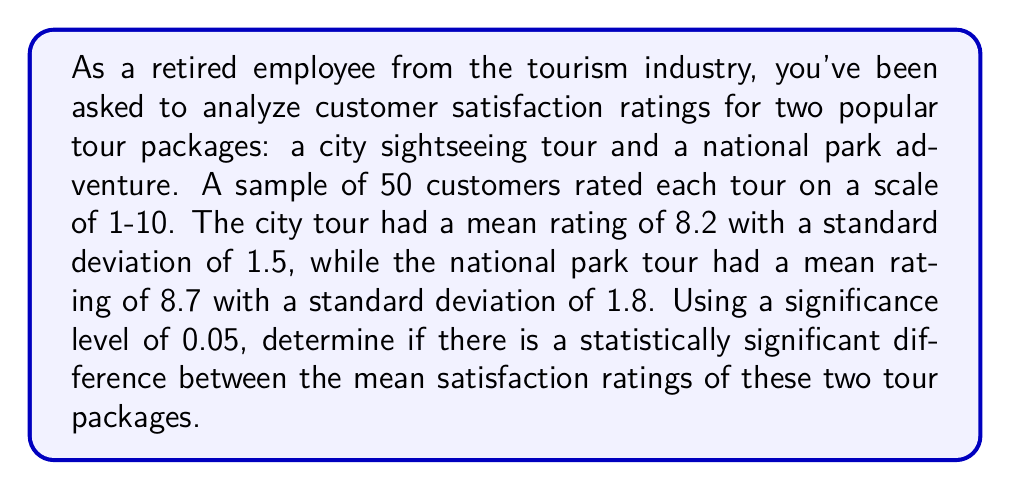Solve this math problem. To determine if there is a statistically significant difference between the mean satisfaction ratings, we'll use a two-sample t-test. We'll follow these steps:

1. State the null and alternative hypotheses:
   $H_0: \mu_1 = \mu_2$ (no difference in mean ratings)
   $H_a: \mu_1 \neq \mu_2$ (there is a difference in mean ratings)

2. Calculate the t-statistic:
   $$t = \frac{\bar{x}_1 - \bar{x}_2}{\sqrt{\frac{s_1^2}{n_1} + \frac{s_2^2}{n_2}}}$$

   Where:
   $\bar{x}_1 = 8.2$ (mean of city tour)
   $\bar{x}_2 = 8.7$ (mean of national park tour)
   $s_1 = 1.5$ (standard deviation of city tour)
   $s_2 = 1.8$ (standard deviation of national park tour)
   $n_1 = n_2 = 50$ (sample size for each tour)

3. Plug in the values:
   $$t = \frac{8.2 - 8.7}{\sqrt{\frac{1.5^2}{50} + \frac{1.8^2}{50}}} = \frac{-0.5}{\sqrt{0.045 + 0.0648}} = \frac{-0.5}{\sqrt{0.1098}} = \frac{-0.5}{0.3313} = -1.509$$

4. Calculate the degrees of freedom (df) using the Welch–Satterthwaite equation:
   $$df = \frac{(\frac{s_1^2}{n_1} + \frac{s_2^2}{n_2})^2}{\frac{(s_1^2/n_1)^2}{n_1-1} + \frac{(s_2^2/n_2)^2}{n_2-1}}$$

   Plugging in the values:
   $$df = \frac{(0.045 + 0.0648)^2}{\frac{0.045^2}{49} + \frac{0.0648^2}{49}} \approx 95.04$$

5. Find the critical t-value for a two-tailed test with $\alpha = 0.05$ and $df = 95$:
   $t_{critical} = \pm 1.985$ (from t-distribution table)

6. Compare the calculated t-statistic to the critical value:
   $|-1.509| < 1.985$

Since the absolute value of our calculated t-statistic is less than the critical value, we fail to reject the null hypothesis.
Answer: We fail to reject the null hypothesis. There is not enough evidence to conclude that there is a statistically significant difference between the mean satisfaction ratings of the city sightseeing tour and the national park adventure tour at the 0.05 significance level. 